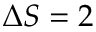<formula> <loc_0><loc_0><loc_500><loc_500>\Delta S = 2</formula> 